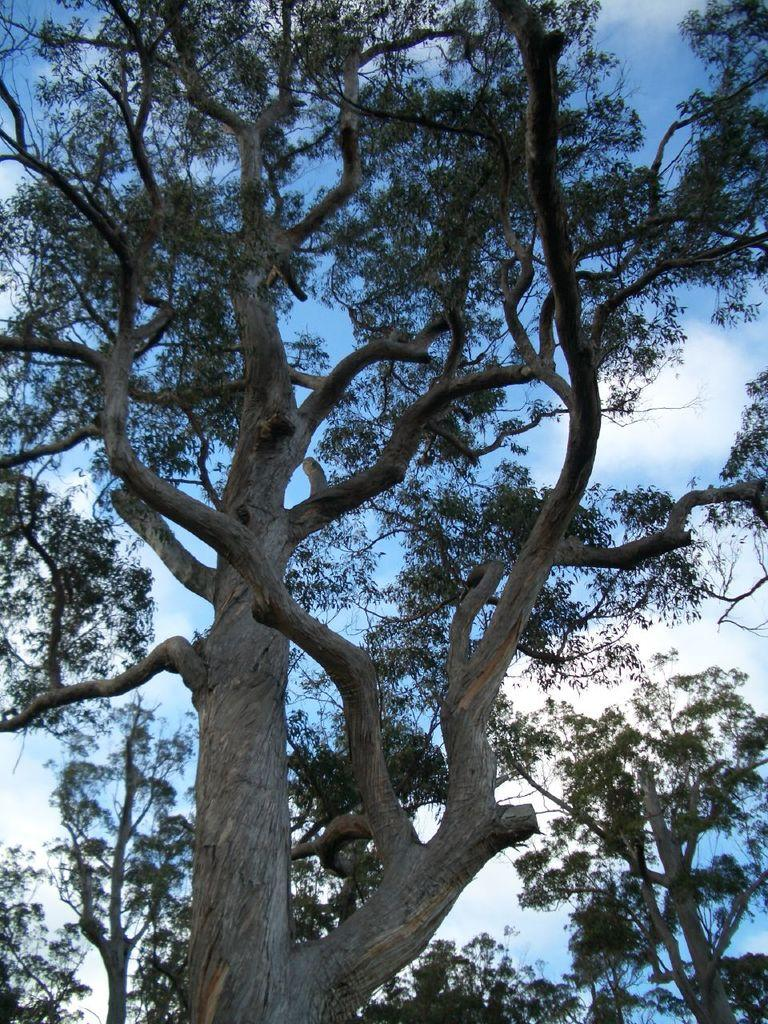What type of vegetation can be seen in the image? There are trees in the image. What is the condition of the sky in the image? The sky is cloudy in the image. What suggestion is being made by the trees in the image? There is no suggestion being made by the trees in the image, as trees do not have the ability to make suggestions. 